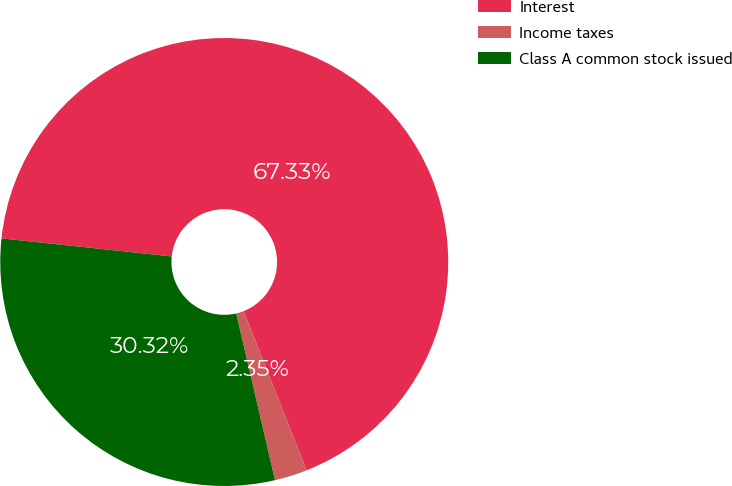<chart> <loc_0><loc_0><loc_500><loc_500><pie_chart><fcel>Interest<fcel>Income taxes<fcel>Class A common stock issued<nl><fcel>67.33%<fcel>2.35%<fcel>30.32%<nl></chart> 